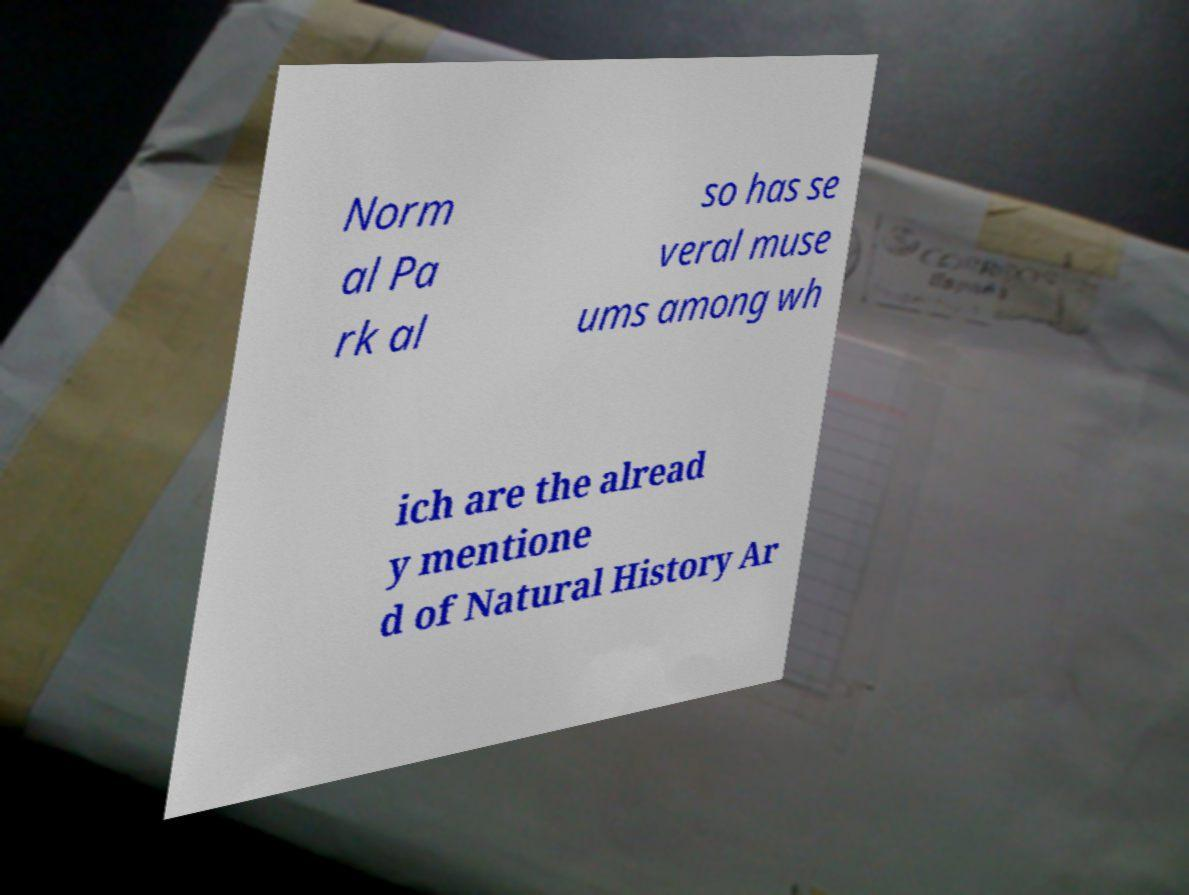Please read and relay the text visible in this image. What does it say? Norm al Pa rk al so has se veral muse ums among wh ich are the alread y mentione d of Natural History Ar 